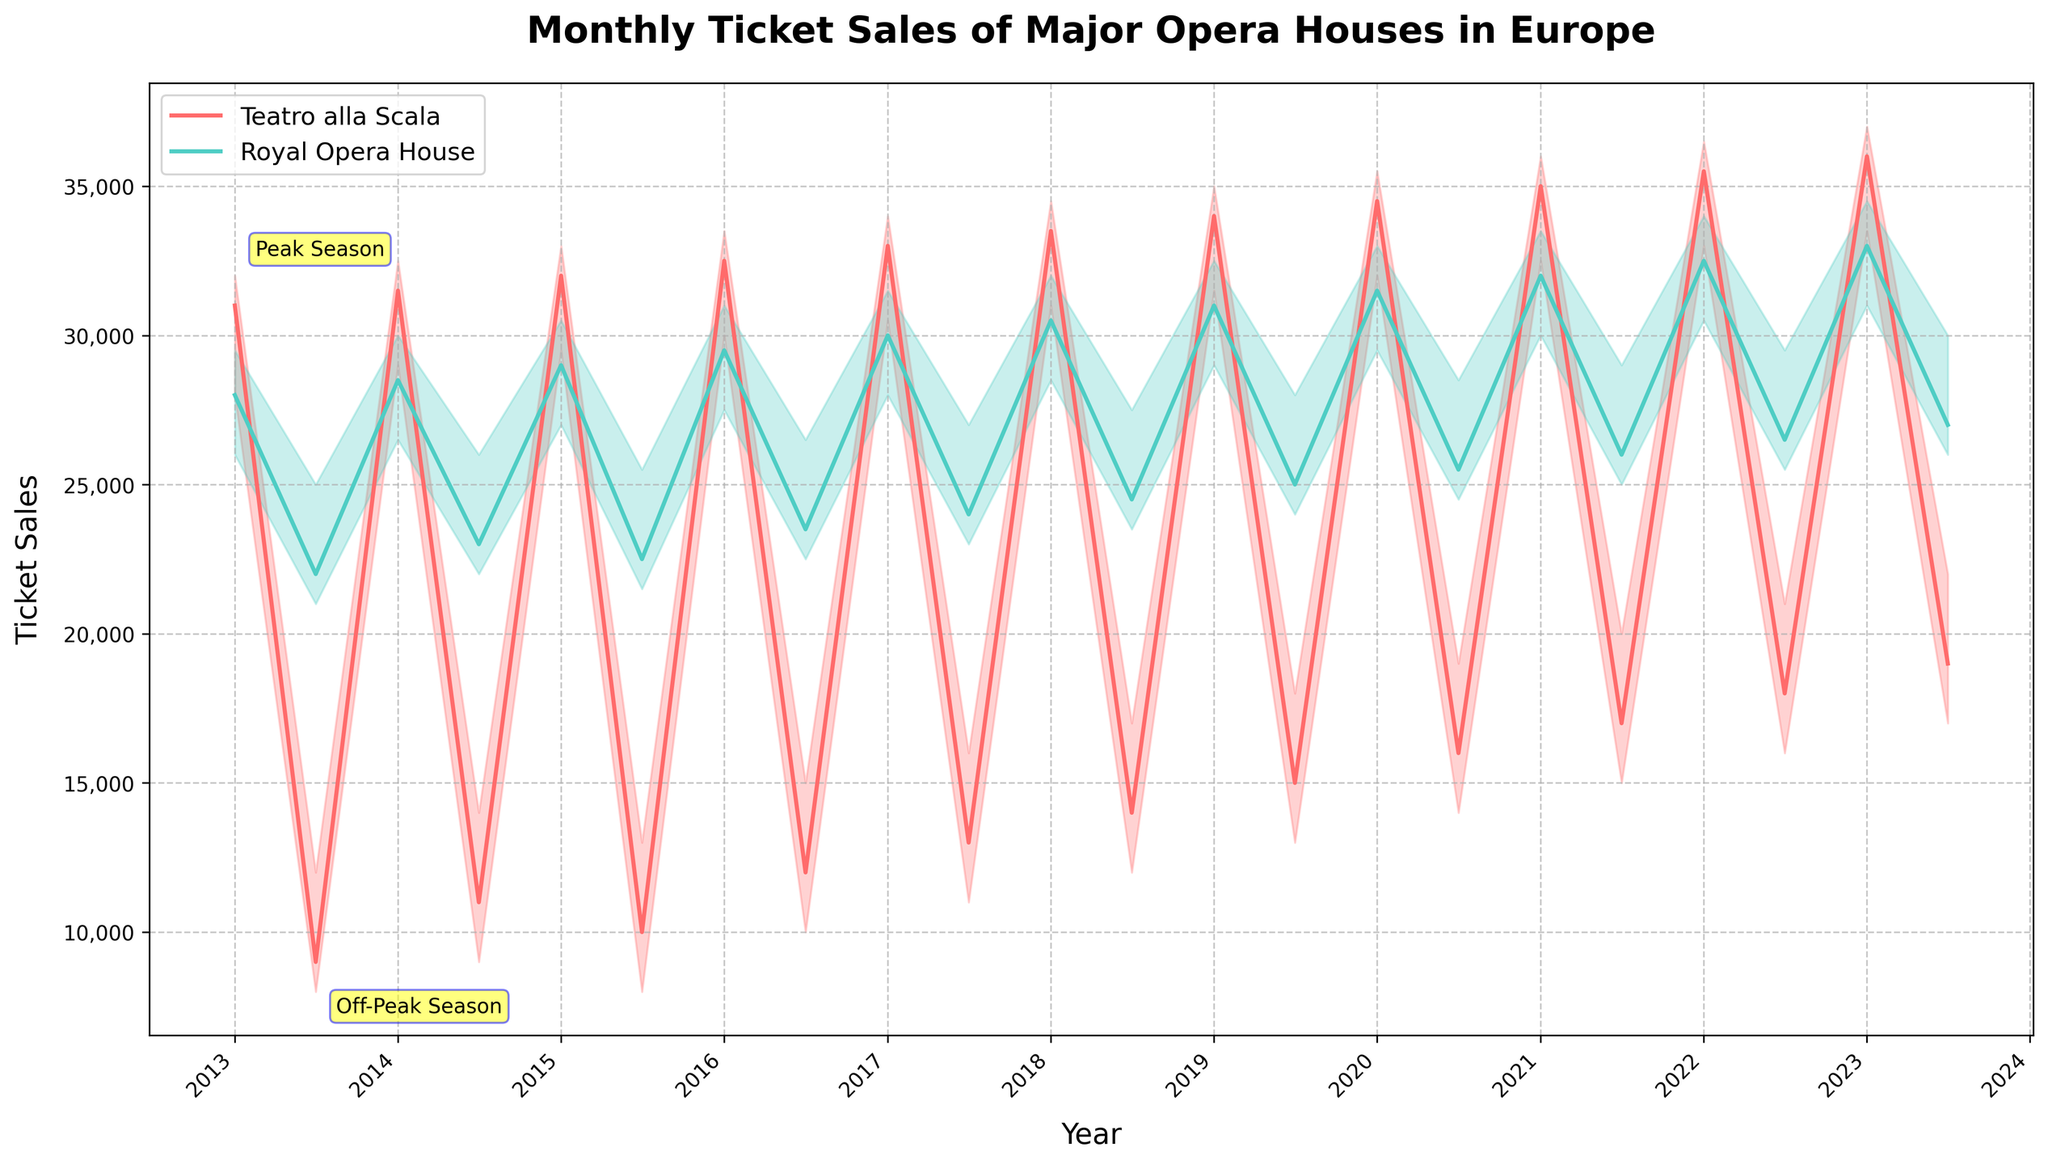What is the title of the plot? The title is located at the top of the plot, and it provides an overview of the subject being visualized. Here, the title is "Monthly Ticket Sales of Major Opera Houses in Europe."
Answer: Monthly Ticket Sales of Major Opera Houses in Europe What are the colors used to represent the two opera houses? The colors help distinguish between the two datasets in the plot. Looking at the lines and shaded areas, Teatro alla Scala is represented by a red color, and Royal Opera House by a cyan color.
Answer: Red and Cyan Which opera house had higher ticket sales in January 2022? In the plot, find the data points for January 2022. At these points, compare the closing values (end of the candlestick) for the two opera houses. Royal Opera House shows a higher closing value than Teatro alla Scala in January 2022.
Answer: Royal Opera House During which month and year did Teatro alla Scala have its lowest ticket sales? Look for the lowest point of the candlestick (lowest part of the shaded region) for Teatro alla Scala. It occurs in July 2013.
Answer: July 2013 What is the average peak season ticket sale for Teatro alla Scala over the given years? Identify the high points of the candlesticks for January months (peak season) for Teatro alla Scala, sum these values, and then divide by the number of years (2013-2023 gives 11 years). The values to average are 32000, 32500, 33000, 33500, 34000, 34500, 35000, 35500, 36000, 36500, 37000. Average is (32000+32500+33000+33500+34000+34500+35000+35500+36000+36500+37000)/11 = 34,500
Answer: 34,500 How did ticket sales for Teatro alla Scala change from January 2020 to July 2020? Compare the closing values of the candlestick for Teatro alla Scala in January 2020 and July 2020. January 2020 had a closing value of 34500, and July 2020 had 16000. The reduction is 34500 - 16000 = 18500.
Answer: Decreased by 18500 Which month is marked as "Peak Season" in the plot and what value is annotated? Look at the annotations on the plot. The "Peak Season" annotation is attached to January 2013, and it marks the highest value at that point which is 32000.
Answer: January 2013 and 32000 Between 2013 and 2023, in how many peak months did the Royal Opera House close above 30000 tickets? Identify the closing values for Royal Opera House in January months. Check how many times these values are greater than 30000: January 2019 (31000), January 2020 (31500), January 2021 (32000), January 2022 (32500), and January 2023 (33000). This occurs 5 times.
Answer: 5 times What is the median ticket sale for Royal Opera House during off-peak months from 2013 to 2023? Gather the closing values for July months from the plot: 22000, 23000, 22500, 23500, 24000, 24500, 25000, 25500, 26000, 26500, and 27000. Sort these values and find the middle value, i.e., 11/2 = 5.5 so the 6th value is the median. Sorted values: 22000, 22500, 23000, 23500, 24000, 24500, 25000, 25500, 26000, 26500, 27000 (median is 24500).
Answer: 24500 